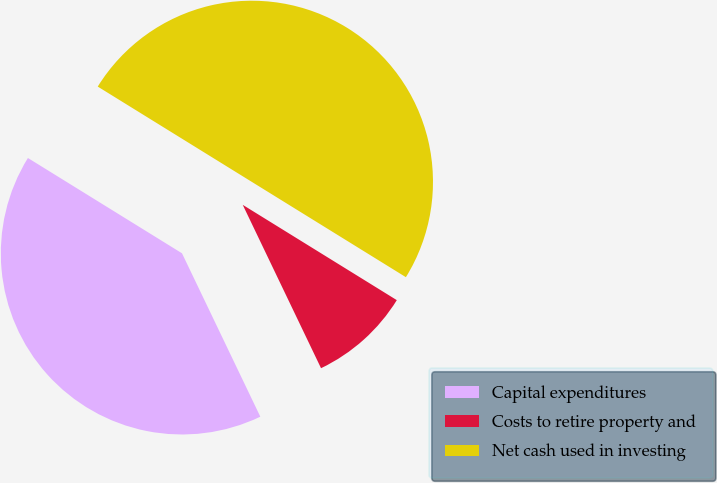Convert chart to OTSL. <chart><loc_0><loc_0><loc_500><loc_500><pie_chart><fcel>Capital expenditures<fcel>Costs to retire property and<fcel>Net cash used in investing<nl><fcel>40.93%<fcel>9.07%<fcel>50.0%<nl></chart> 